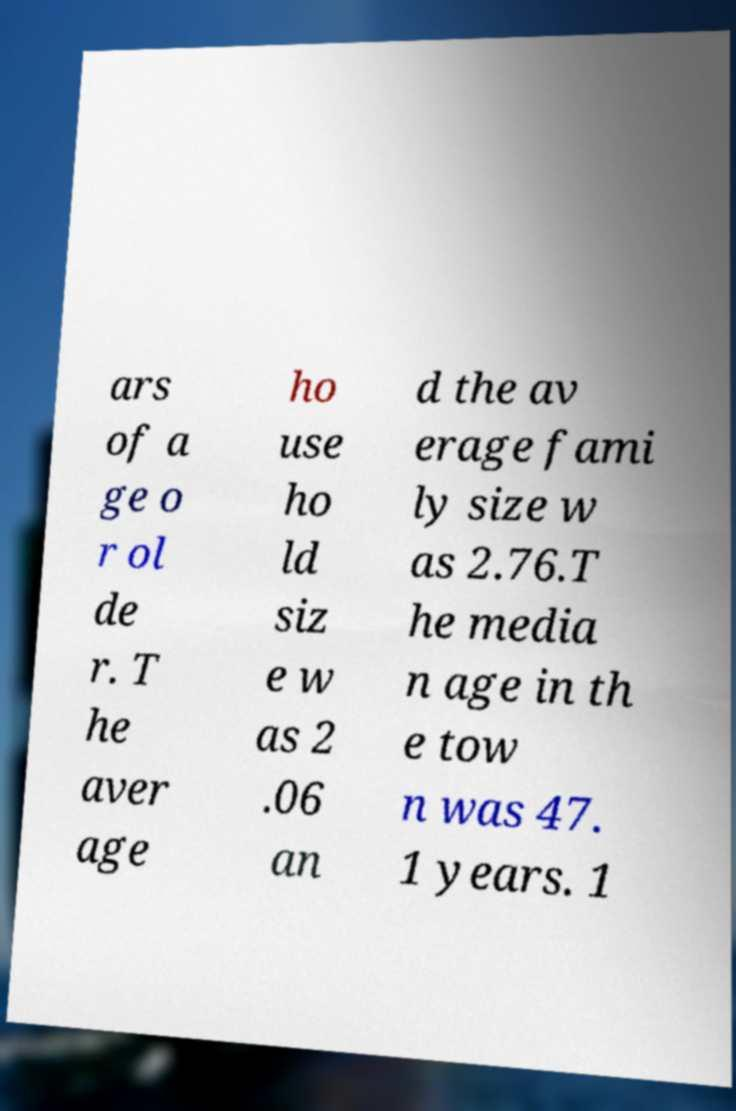Can you accurately transcribe the text from the provided image for me? ars of a ge o r ol de r. T he aver age ho use ho ld siz e w as 2 .06 an d the av erage fami ly size w as 2.76.T he media n age in th e tow n was 47. 1 years. 1 